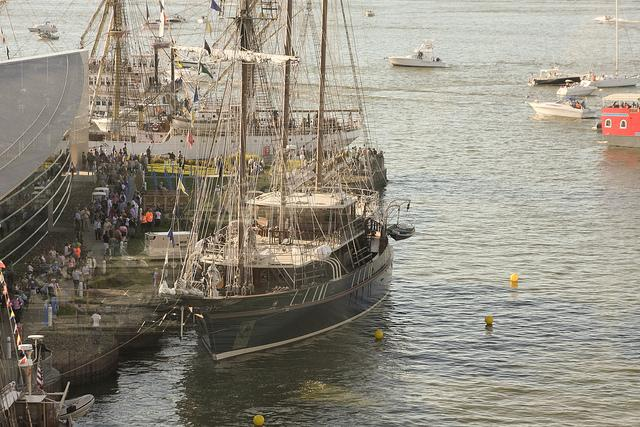How many sail posts are on the back of this historic sailing ship?

Choices:
A) four
B) three
C) five
D) two three 